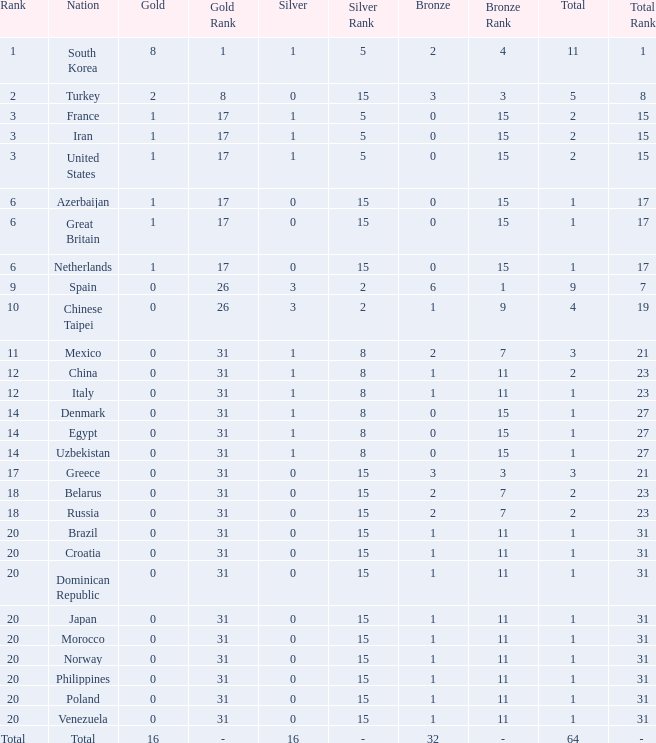What is the average number of bronze medals of the Philippines, which has more than 0 gold? None. 